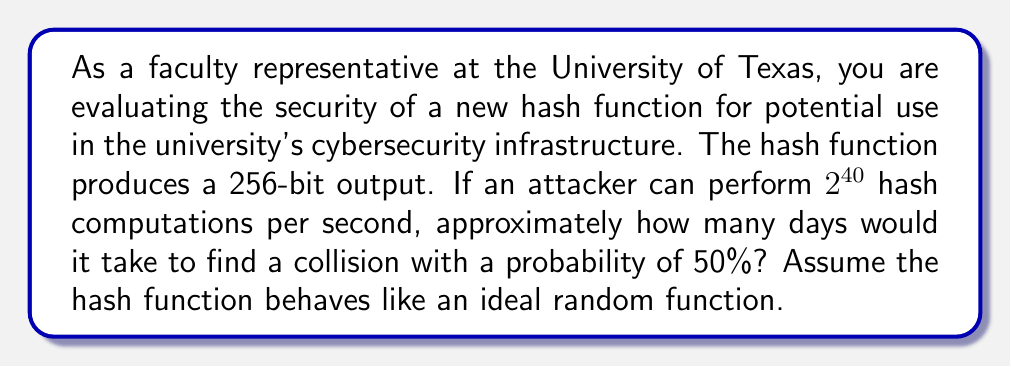Can you answer this question? To solve this problem, we'll use the birthday attack principle and follow these steps:

1) For a hash function with an n-bit output, the number of hash computations needed for a 50% probability of finding a collision is approximately $\sqrt{2^{n+1}}$.

2) In this case, n = 256, so the number of computations needed is:
   $$\sqrt{2^{257}} = 2^{128.5}$$

3) The attacker can perform $2^{40}$ computations per second. To find the time in seconds, we divide the total computations by the rate:
   $$\frac{2^{128.5}}{2^{40}} = 2^{88.5}$$ seconds

4) To convert seconds to days, we divide by the number of seconds in a day (86,400):
   $$\frac{2^{88.5}}{86400} \approx 2^{88.5 - 16.4} = 2^{72.1}$$ days

5) $2^{72.1}$ is approximately equal to $4.7 \times 10^{21}$ days

This extremely large number of days demonstrates the high collision resistance of the hash function, indicating strong security for practical purposes.
Answer: $4.7 \times 10^{21}$ days 